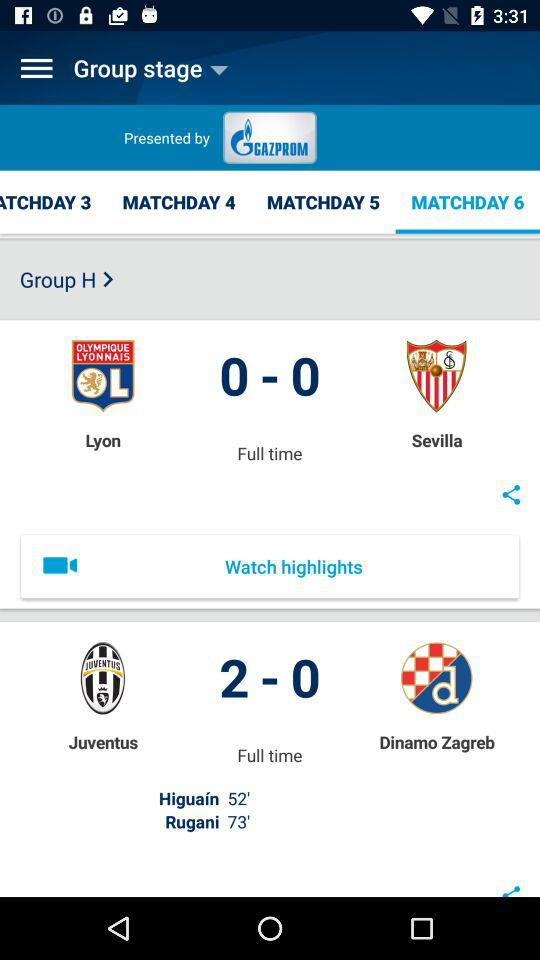How many goals were scored in the match between Juventus and Dinamo Zagreb?
Answer the question using a single word or phrase. 2 